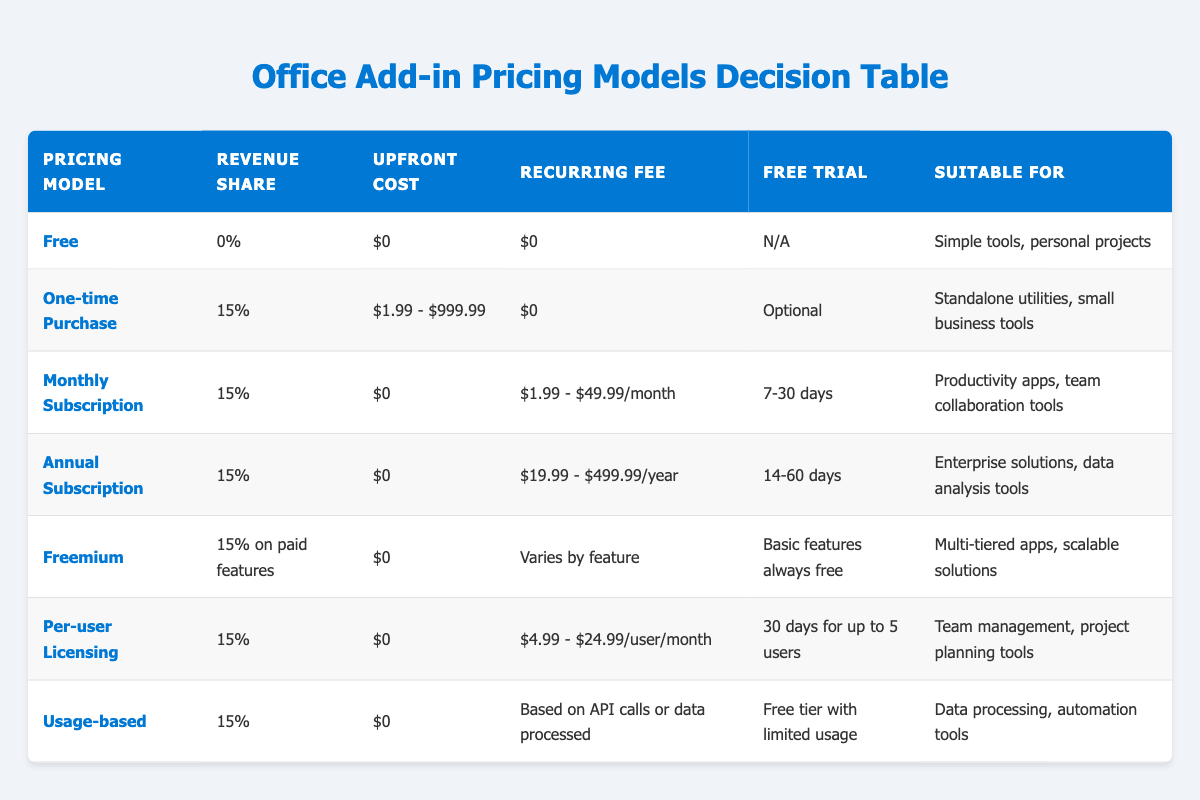What is the revenue share for the "Freemium" pricing model? The value listed in the "Revenue Share" column for the "Freemium" pricing model is 15% on paid features.
Answer: 15% on paid features Which pricing model has an upfront cost of "$0"? All rows that have "$0" listed in the "Upfront Cost" column include: Monthly Subscription, Annual Subscription, Freemium, Per-user Licensing, and Usage-based.
Answer: Monthly Subscription, Annual Subscription, Freemium, Per-user Licensing, Usage-based What is the highest recurring fee for a monthly subscription? According to the "Recurring Fee" column, the maximum value is $49.99/month for the Monthly Subscription pricing model.
Answer: $49.99/month Is there a free trial available for the "Per-user Licensing" model? The "Free Trial" column for the Per-user Licensing model specifies a trial period of 30 days for up to 5 users, thus confirming a free trial is available.
Answer: Yes Which pricing model is suitable for enterprise solutions? The "Suitable for" column lists "Enterprise solutions, data analysis tools" under the Annual Subscription pricing model.
Answer: Annual Subscription What is the difference between the upfront costs of the "One-time Purchase" and "Annual Subscription" models? The "One-time Purchase" has an upfront cost ranging from $1.99 to $999.99, while the "Annual Subscription" has an upfront cost of $0. Therefore, the difference in upfront costs is $1.99 - $0 = $1.99.
Answer: $1.99 Which pricing model offers a recurring fee based on usage? The "Usage-based" pricing model has a recurring fee that is defined as "Based on API calls or data processed," which indicates variability based on usage.
Answer: Usage-based What is the suitable application for "Monthly Subscription" pricing? Referring to the "Suitable for" column, it is stated that the Monthly Subscription is suitable for "Productivity apps, team collaboration tools."
Answer: Productivity apps, team collaboration tools Which pricing model has a free trial period of 14-60 days? The "Free Trial" column indicates that the Annual Subscription pricing model offers a free trial period of 14-60 days.
Answer: Annual Subscription 